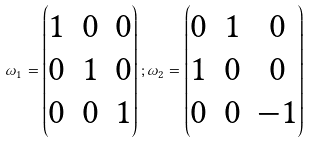Convert formula to latex. <formula><loc_0><loc_0><loc_500><loc_500>\omega _ { 1 } = \begin{pmatrix} 1 & 0 & 0 \\ 0 & 1 & 0 \\ 0 & 0 & 1 \end{pmatrix} ; \omega _ { 2 } = \begin{pmatrix} 0 & 1 & 0 \\ 1 & 0 & 0 \\ 0 & 0 & - 1 \end{pmatrix}</formula> 